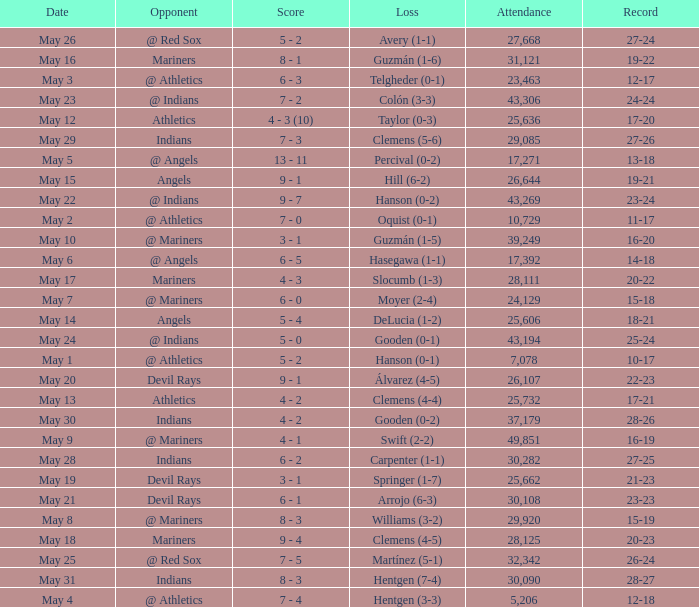When was the record 27-25? May 28. 